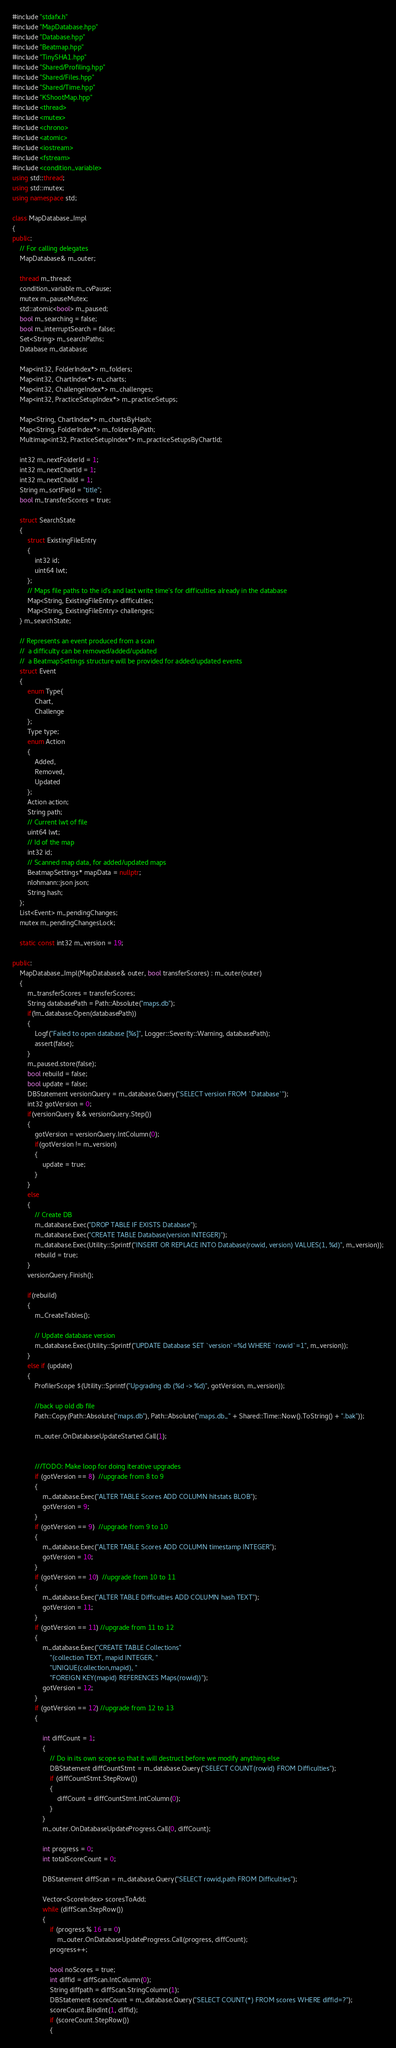<code> <loc_0><loc_0><loc_500><loc_500><_C++_>#include "stdafx.h"
#include "MapDatabase.hpp"
#include "Database.hpp"
#include "Beatmap.hpp"
#include "TinySHA1.hpp"
#include "Shared/Profiling.hpp"
#include "Shared/Files.hpp"
#include "Shared/Time.hpp"
#include "KShootMap.hpp"
#include <thread>
#include <mutex>
#include <chrono>
#include <atomic>
#include <iostream>
#include <fstream>
#include <condition_variable>
using std::thread;
using std::mutex;
using namespace std;

class MapDatabase_Impl
{
public:
	// For calling delegates
	MapDatabase& m_outer;

	thread m_thread;
	condition_variable m_cvPause;
	mutex m_pauseMutex;
	std::atomic<bool> m_paused;
	bool m_searching = false;
	bool m_interruptSearch = false;
	Set<String> m_searchPaths;
	Database m_database;

	Map<int32, FolderIndex*> m_folders;
	Map<int32, ChartIndex*> m_charts;
	Map<int32, ChallengeIndex*> m_challenges;
	Map<int32, PracticeSetupIndex*> m_practiceSetups;

	Map<String, ChartIndex*> m_chartsByHash;
	Map<String, FolderIndex*> m_foldersByPath;
	Multimap<int32, PracticeSetupIndex*> m_practiceSetupsByChartId;

	int32 m_nextFolderId = 1;
	int32 m_nextChartId = 1;
	int32 m_nextChalId = 1;
	String m_sortField = "title";
	bool m_transferScores = true;

	struct SearchState
	{
		struct ExistingFileEntry
		{
			int32 id;
			uint64 lwt;
		};
		// Maps file paths to the id's and last write time's for difficulties already in the database
		Map<String, ExistingFileEntry> difficulties;
		Map<String, ExistingFileEntry> challenges;
	} m_searchState;

	// Represents an event produced from a scan
	//	a difficulty can be removed/added/updated
	//	a BeatmapSettings structure will be provided for added/updated events
	struct Event
	{
		enum Type{
			Chart,
			Challenge
		};
		Type type;
		enum Action
		{
			Added,
			Removed,
			Updated
		};
		Action action;
		String path;
		// Current lwt of file
		uint64 lwt;
		// Id of the map
		int32 id;
		// Scanned map data, for added/updated maps
		BeatmapSettings* mapData = nullptr;
		nlohmann::json json;
		String hash;
	};
	List<Event> m_pendingChanges;
	mutex m_pendingChangesLock;

	static const int32 m_version = 19;

public:
	MapDatabase_Impl(MapDatabase& outer, bool transferScores) : m_outer(outer)
	{
		m_transferScores = transferScores;
		String databasePath = Path::Absolute("maps.db");
		if(!m_database.Open(databasePath))
		{
			Logf("Failed to open database [%s]", Logger::Severity::Warning, databasePath);
			assert(false);
		}
		m_paused.store(false);
		bool rebuild = false;
		bool update = false;
		DBStatement versionQuery = m_database.Query("SELECT version FROM `Database`");
		int32 gotVersion = 0;
		if(versionQuery && versionQuery.Step())
		{
			gotVersion = versionQuery.IntColumn(0);
			if(gotVersion != m_version)
			{
				update = true;
			}
		}
		else
		{
			// Create DB 
			m_database.Exec("DROP TABLE IF EXISTS Database");
			m_database.Exec("CREATE TABLE Database(version INTEGER)");
			m_database.Exec(Utility::Sprintf("INSERT OR REPLACE INTO Database(rowid, version) VALUES(1, %d)", m_version));
			rebuild = true;
		}
		versionQuery.Finish();

		if(rebuild)
		{
			m_CreateTables();

			// Update database version
			m_database.Exec(Utility::Sprintf("UPDATE Database SET `version`=%d WHERE `rowid`=1", m_version));
		}
		else if (update)
		{
			ProfilerScope $(Utility::Sprintf("Upgrading db (%d -> %d)", gotVersion, m_version));

			//back up old db file
			Path::Copy(Path::Absolute("maps.db"), Path::Absolute("maps.db_" + Shared::Time::Now().ToString() + ".bak"));

			m_outer.OnDatabaseUpdateStarted.Call(1);


			///TODO: Make loop for doing iterative upgrades
			if (gotVersion == 8)  //upgrade from 8 to 9
			{
				m_database.Exec("ALTER TABLE Scores ADD COLUMN hitstats BLOB");
				gotVersion = 9;
			}
			if (gotVersion == 9)  //upgrade from 9 to 10
			{
				m_database.Exec("ALTER TABLE Scores ADD COLUMN timestamp INTEGER");
				gotVersion = 10;
			}
			if (gotVersion == 10)  //upgrade from 10 to 11
			{
				m_database.Exec("ALTER TABLE Difficulties ADD COLUMN hash TEXT");
				gotVersion = 11;
			}
			if (gotVersion == 11) //upgrade from 11 to 12
			{
				m_database.Exec("CREATE TABLE Collections"
					"(collection TEXT, mapid INTEGER, "
					"UNIQUE(collection,mapid), "
					"FOREIGN KEY(mapid) REFERENCES Maps(rowid))");
				gotVersion = 12;
			}
			if (gotVersion == 12) //upgrade from 12 to 13
			{

				int diffCount = 1;
				{
					// Do in its own scope so that it will destruct before we modify anything else
					DBStatement diffCountStmt = m_database.Query("SELECT COUNT(rowid) FROM Difficulties");
					if (diffCountStmt.StepRow())
					{
						diffCount = diffCountStmt.IntColumn(0);
					}
				}
				m_outer.OnDatabaseUpdateProgress.Call(0, diffCount);

				int progress = 0;
				int totalScoreCount = 0;

				DBStatement diffScan = m_database.Query("SELECT rowid,path FROM Difficulties");

				Vector<ScoreIndex> scoresToAdd;
				while (diffScan.StepRow())
				{
					if (progress % 16 == 0)
						m_outer.OnDatabaseUpdateProgress.Call(progress, diffCount);
					progress++;

					bool noScores = true;
					int diffid = diffScan.IntColumn(0);
					String diffpath = diffScan.StringColumn(1);
					DBStatement scoreCount = m_database.Query("SELECT COUNT(*) FROM scores WHERE diffid=?");
					scoreCount.BindInt(1, diffid);
					if (scoreCount.StepRow())
					{</code> 